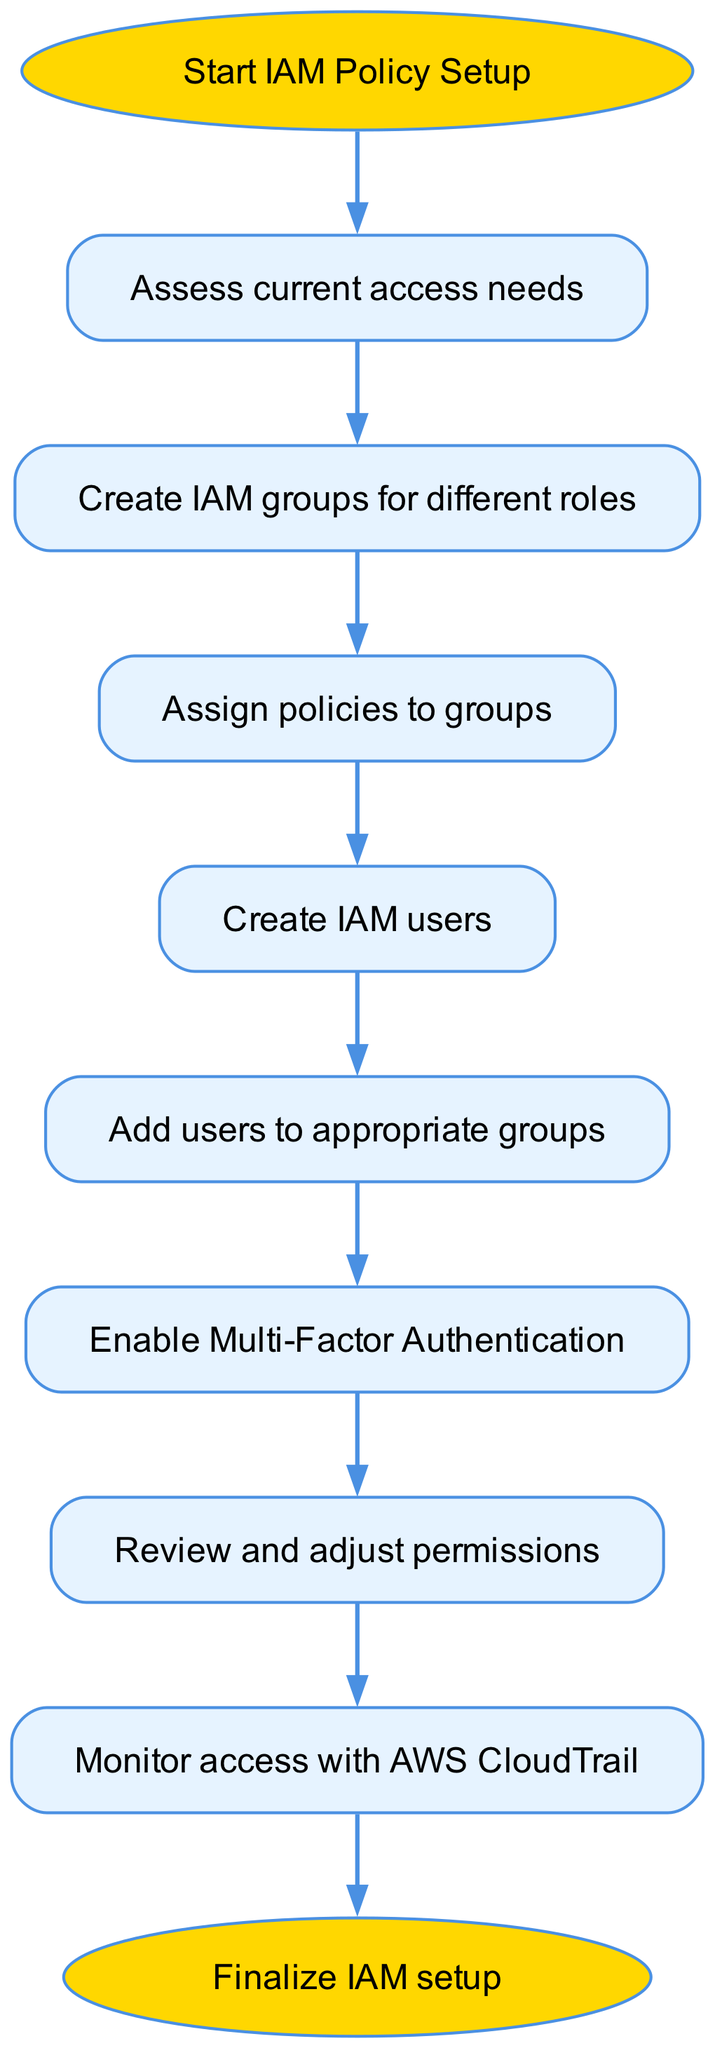What is the first step in the IAM policy setup workflow? The first step is indicated by the starting node, which states "Start IAM Policy Setup." This is the entry point for the entire workflow.
Answer: Start IAM Policy Setup How many nodes are there in the workflow diagram? By counting all the elements listed in the diagram, there are ten nodes in total, including both the start and end nodes of the workflow.
Answer: 10 What is the outcome after assigning policies to groups? After assigning policies to groups, the next step in the workflow is to "Create IAM users." This implies the objective of the prior step leads to this stage.
Answer: Create IAM users Which node follows the step of enabling Multi-Factor Authentication? The node that follows "Enable Multi-Factor Authentication" is "Review and adjust permissions." This shows the sequential flow from security setup to permissions evaluation.
Answer: Review and adjust permissions What action is taken after adding users to appropriate groups? The subsequent action after adding users to groups is "Enable Multi-Factor Authentication." This indicates a focus on enhancing security measures for newly added users.
Answer: Enable Multi-Factor Authentication Which two steps are directly connected by an edge in the flowchart? An edge connects "Review and adjust permissions" to "Monitor access with AWS CloudTrail." This shows the progression from reviewing permissions to monitoring access activities.
Answer: Review and adjust permissions to Monitor access with AWS CloudTrail What is the last step in the IAM policy setup workflow? The last step is indicated in the workflow with the node labeled "Finalize IAM setup," which signifies the completion of the entire IAM setup process.
Answer: Finalize IAM setup What role does AWS CloudTrail play in the IAM workflow? AWS CloudTrail's role is depicted in the step labeled "Monitor access with AWS CloudTrail," where it is used for tracking access to ensure compliance and security observations.
Answer: Monitor access with AWS CloudTrail What action is performed right after the creation of IAM users? Right after the creation of IAM users, the action that follows is "Add users to appropriate groups," indicating the organization of users within the IAM framework.
Answer: Add users to appropriate groups 